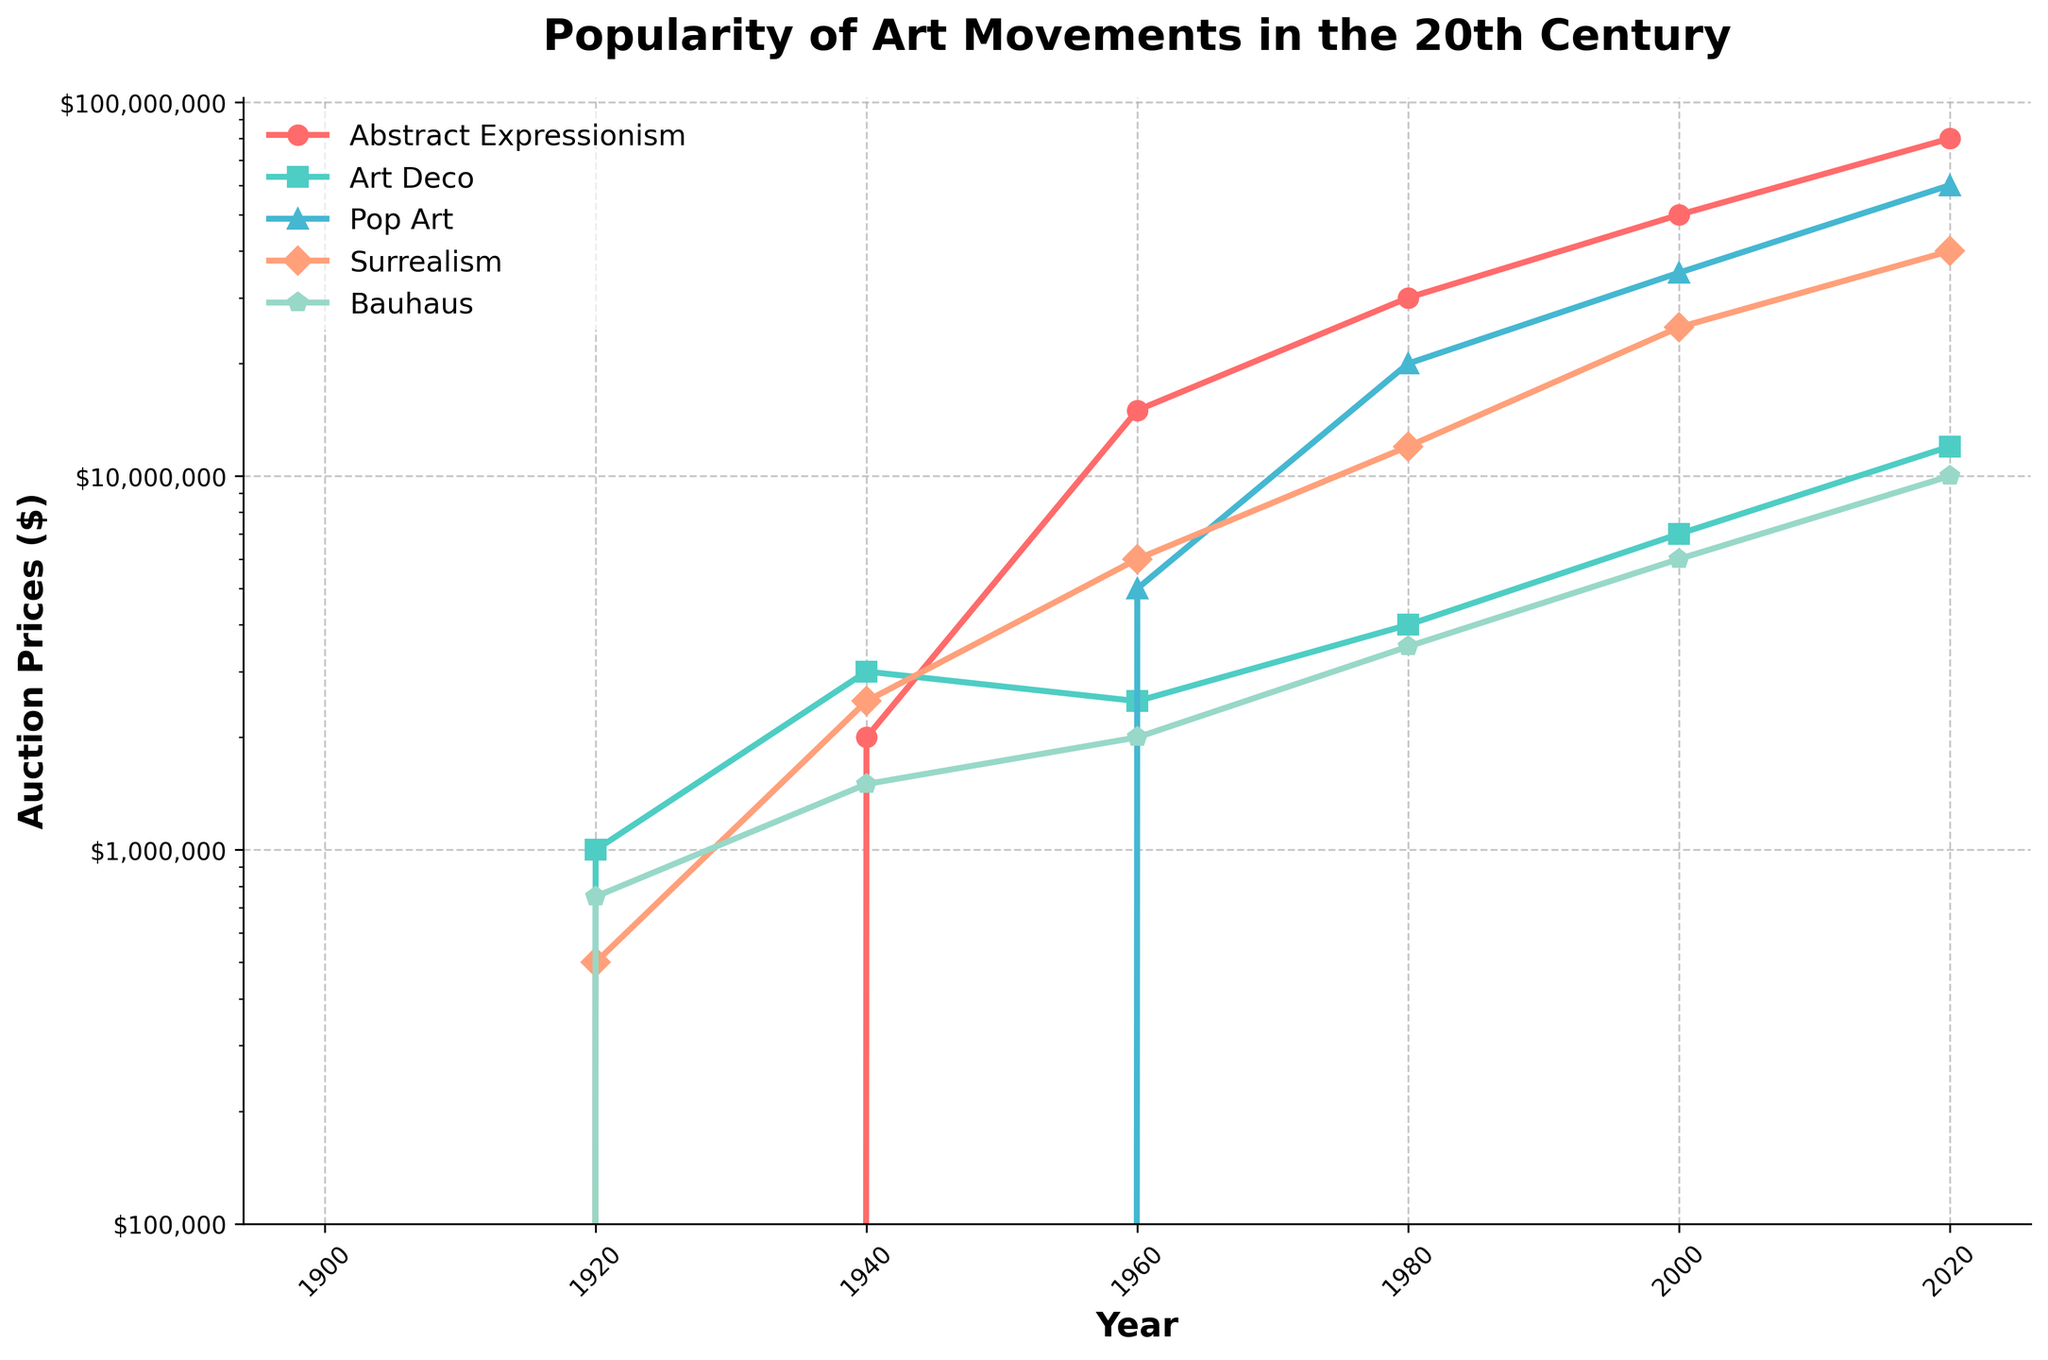What was the auction price of Art Deco in 1920? Look at the figure on the line for Art Deco at the point corresponding to the year 1920. The value shown is $1,000,000.
Answer: $1,000,000 Which art movement had the highest auction price in 1960? Compare the auction prices of all the art movements for the year 1960. Abstract Expressionism has the highest value at $15,000,000.
Answer: Abstract Expressionism Between Bauhaus and Surrealism, which had a higher auction price in 1940? Look at the auction prices of Bauhaus and Surrealism for the year 1940. Surrealism was at $2,500,000 while Bauhaus was at $1,500,000, so Surrealism was higher.
Answer: Surrealism How much did the auction price of Pop Art increase from 1960 to 2000? In 1960, the auction price of Pop Art was $5,000,000. In 2000, it was $35,000,000. The increase is $35,000,000 - $5,000,000 = $30,000,000.
Answer: $30,000,000 Which art movement showed the highest increase in auction prices from 1980 to 2020? Calculate the increase in auction prices for each art movement between 1980 and 2020. Abstract Expressionism increased from $30,000,000 to $80,000,000, Art Deco from $4,000,000 to $12,000,000, Pop Art from $20,000,000 to $60,000,000, Surrealism from $12,000,000 to $40,000,000, Bauhaus from $3,500,000 to $10,000,000. Abstract Expressionism had the highest increase of $50,000,000.
Answer: Abstract Expressionism What is the auction price difference between Art Deco and Pop Art in 2020? The auction price of Art Deco in 2020 is $12,000,000, and for Pop Art, it is $60,000,000. The difference is $60,000,000 - $12,000,000 = $48,000,000.
Answer: $48,000,000 Which art movement had the steepest decline from 1940 to 1960? Compare the changes in auction prices for each art movement from 1940 to 1960. Abstract Expressionism increased, Art Deco decreased from $3,000,000 to $2,500,000, Pop Art appeared on the chart, Surrealism increased significantly, Bauhaus increased. Art Deco had a decline of $500,000.
Answer: Art Deco How did the popularity of Surrealism change between 1920 and 2020? Compare the auction price of Surrealism between 1920 and 2020. It started at $500,000 in 1920 and increased to $40,000,000 in 2020.
Answer: Increased from $500,000 to $40,000,000 Which art movement had the highest value in 1980 and what was it? In 1980, the auction prices are shown and Abstract Expressionism had the highest value at $30,000,000.
Answer: Abstract Expressionism, $30,000,000 